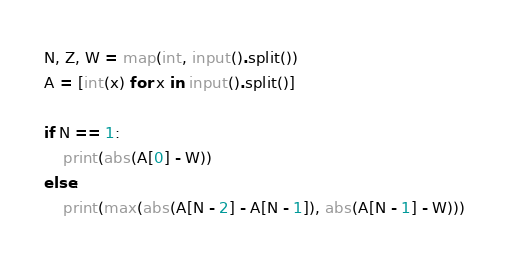Convert code to text. <code><loc_0><loc_0><loc_500><loc_500><_Python_>N, Z, W = map(int, input().split())
A = [int(x) for x in input().split()]

if N == 1:
    print(abs(A[0] - W))
else:
    print(max(abs(A[N - 2] - A[N - 1]), abs(A[N - 1] - W)))</code> 